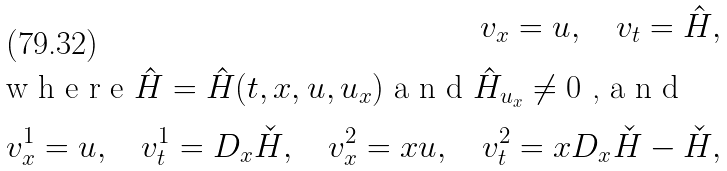Convert formula to latex. <formula><loc_0><loc_0><loc_500><loc_500>v _ { x } = u , \quad v _ { t } = \hat { H } , \\ \intertext { w h e r e $ \hat { H } = \hat { H } ( t , x , u , u _ { x } ) $ a n d $ \hat { H } _ { u _ { x } } \ne 0 $ , a n d } v ^ { 1 } _ { x } = u , \quad v ^ { 1 } _ { t } = D _ { x } \check { H } , \quad v ^ { 2 } _ { x } = x u , \quad v ^ { 2 } _ { t } = x D _ { x } \check { H } - \check { H } ,</formula> 